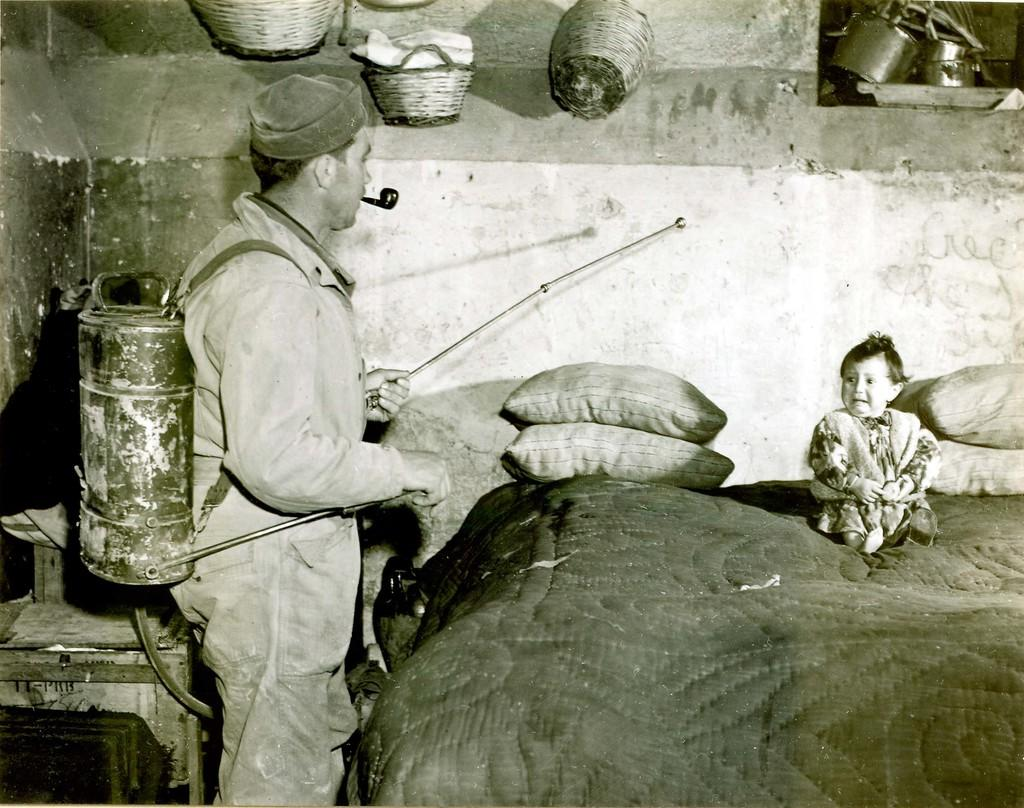What is the baby doing in the image? The baby is sitting on a bed in the image. What is the person holding in the image? The person is holding a water bag in the image. What is the person doing with the water bag? The person is spearing something in the image. What can be seen in the background of the image? There is a wall visible in the image. What is attached to the wall in the image? There are baskets attached to the wall in the image. What type of rings can be seen on the plate in the image? There is no plate or rings present in the image. Is there a garden visible in the image? No, there is no garden visible in the image. 